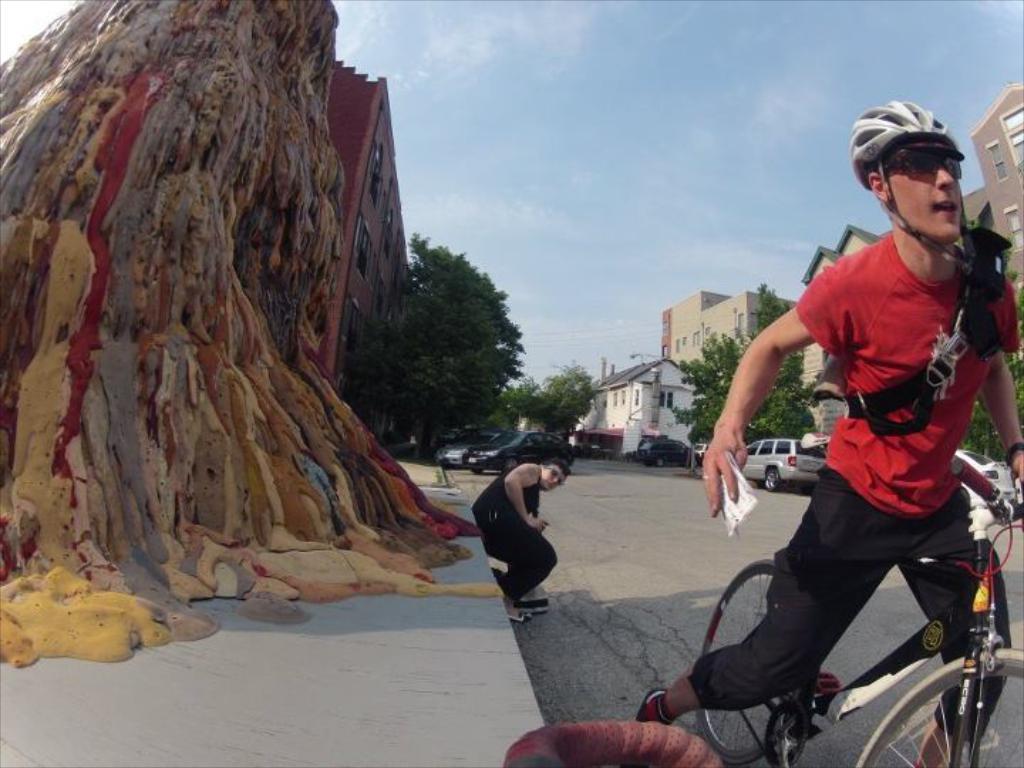In one or two sentences, can you explain what this image depicts? At the top we can see sky with cloud. Across the road we can see vehicles parked near to the buildings. These are trees. Here we can one person in a squat position on the road. We can see one man wearing red shirt wearing goggles, helmet and riding a bicycle on the road. 